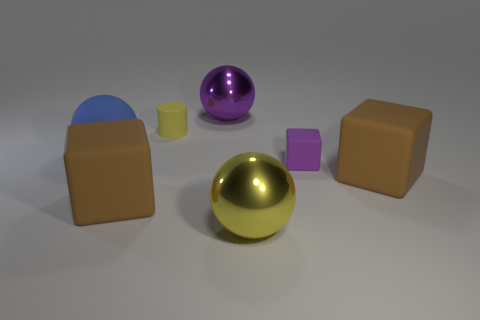What shape is the purple thing that is the same size as the matte ball?
Make the answer very short. Sphere. Do the big sphere behind the blue object and the large brown object to the right of the small yellow rubber object have the same material?
Offer a very short reply. No. How many large matte blocks are there?
Offer a terse response. 2. How many other big shiny things are the same shape as the big blue thing?
Your answer should be compact. 2. Is the large purple metallic thing the same shape as the tiny yellow thing?
Offer a terse response. No. The purple cube is what size?
Your answer should be compact. Small. How many other blue matte things are the same size as the blue matte object?
Your answer should be compact. 0. Does the thing behind the small cylinder have the same size as the brown block that is on the left side of the tiny rubber cube?
Your answer should be very brief. Yes. The small object that is in front of the blue matte thing has what shape?
Your answer should be very brief. Cube. What is the yellow object that is in front of the small matte object that is on the right side of the large yellow metallic sphere made of?
Your response must be concise. Metal. 